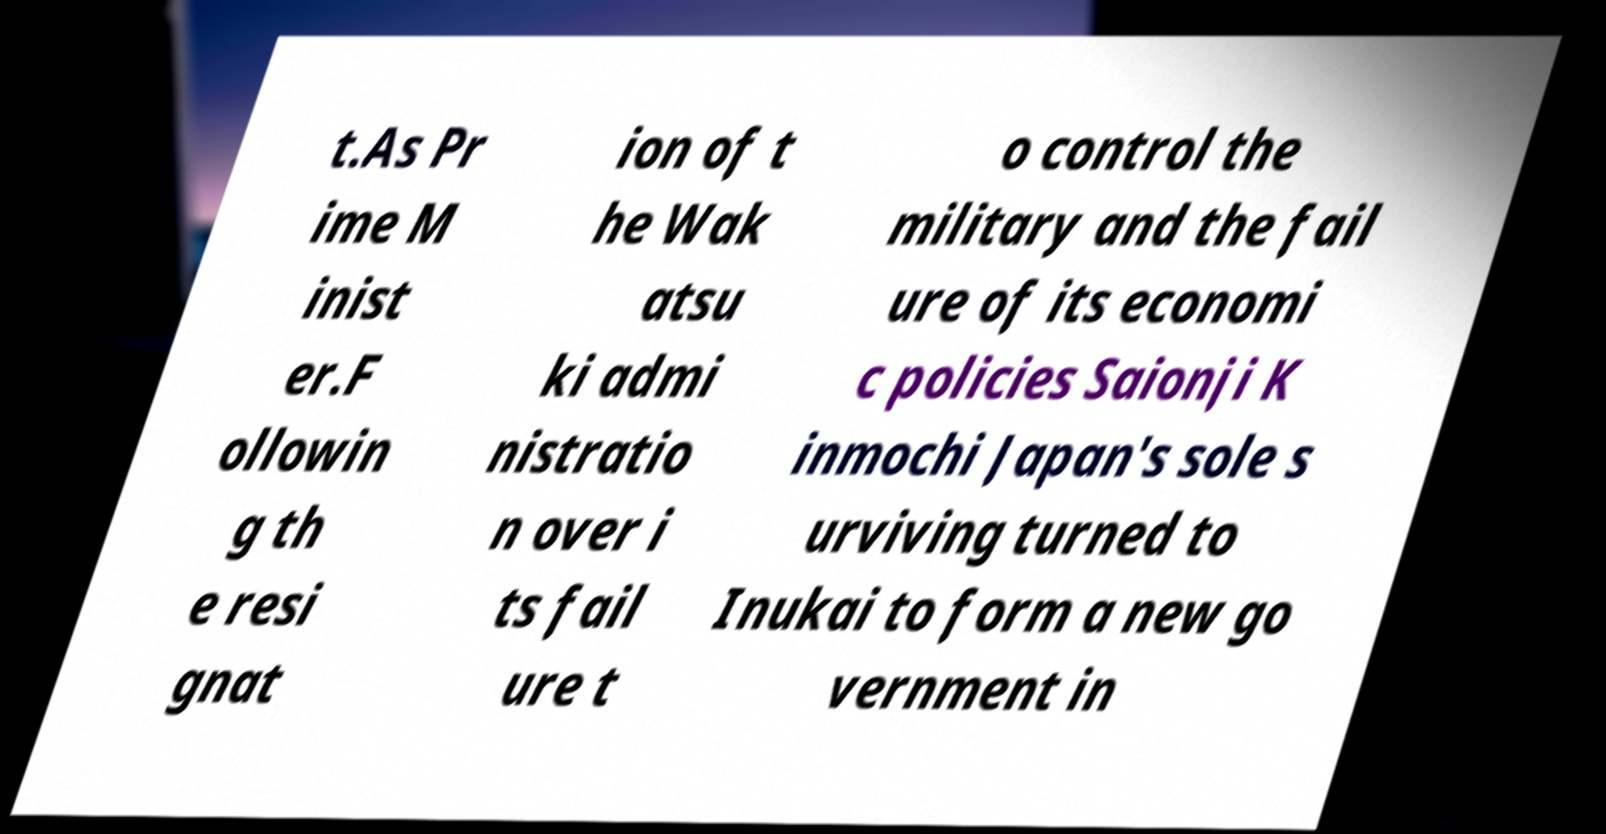Could you extract and type out the text from this image? t.As Pr ime M inist er.F ollowin g th e resi gnat ion of t he Wak atsu ki admi nistratio n over i ts fail ure t o control the military and the fail ure of its economi c policies Saionji K inmochi Japan's sole s urviving turned to Inukai to form a new go vernment in 